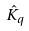<formula> <loc_0><loc_0><loc_500><loc_500>\hat { K } _ { q }</formula> 